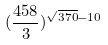<formula> <loc_0><loc_0><loc_500><loc_500>( \frac { 4 5 8 } { 3 } ) ^ { \sqrt { 3 7 0 } - 1 0 }</formula> 